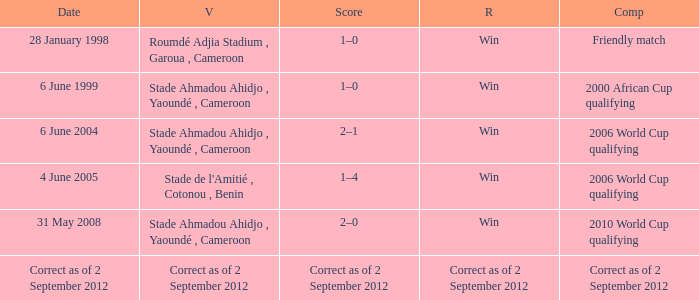What was the result for a friendly match? Win. 